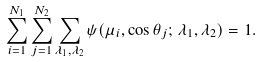Convert formula to latex. <formula><loc_0><loc_0><loc_500><loc_500>\sum _ { i = 1 } ^ { N _ { 1 } } \sum _ { j = 1 } ^ { N _ { 2 } } \sum _ { \lambda _ { 1 } , \lambda _ { 2 } } \psi ( \mu _ { i } , \cos \theta _ { j } ; \, \lambda _ { 1 } , \lambda _ { 2 } ) = 1 .</formula> 